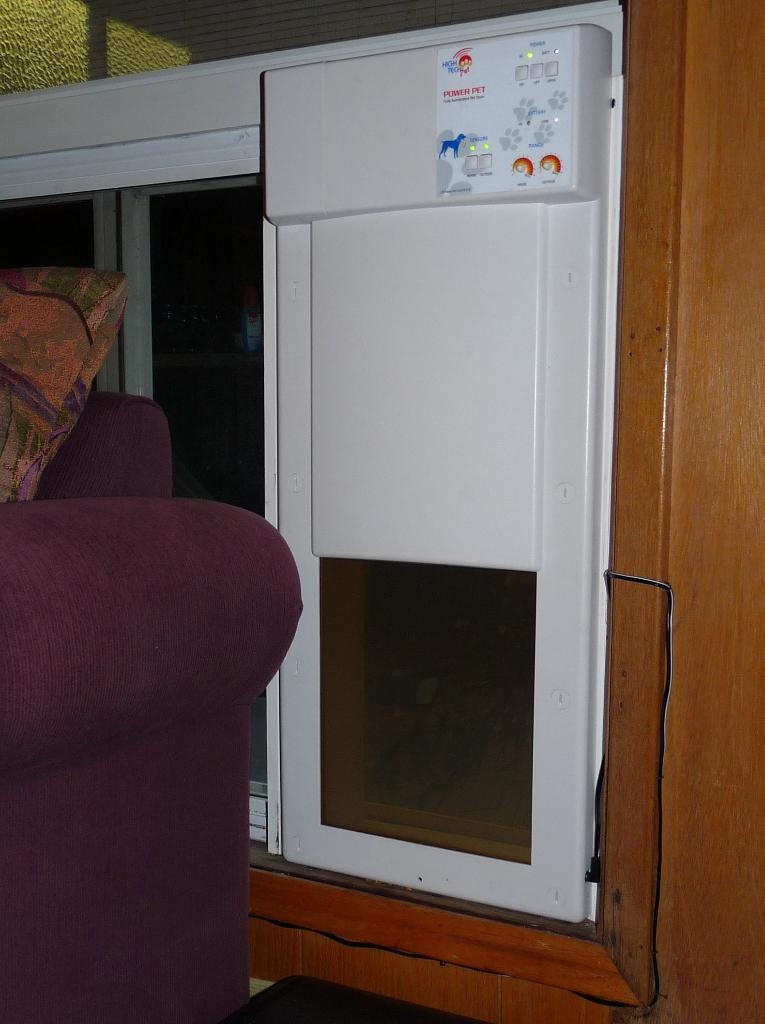<image>
Summarize the visual content of the image. The Power Pet machine seems to be embedded into the wall. 